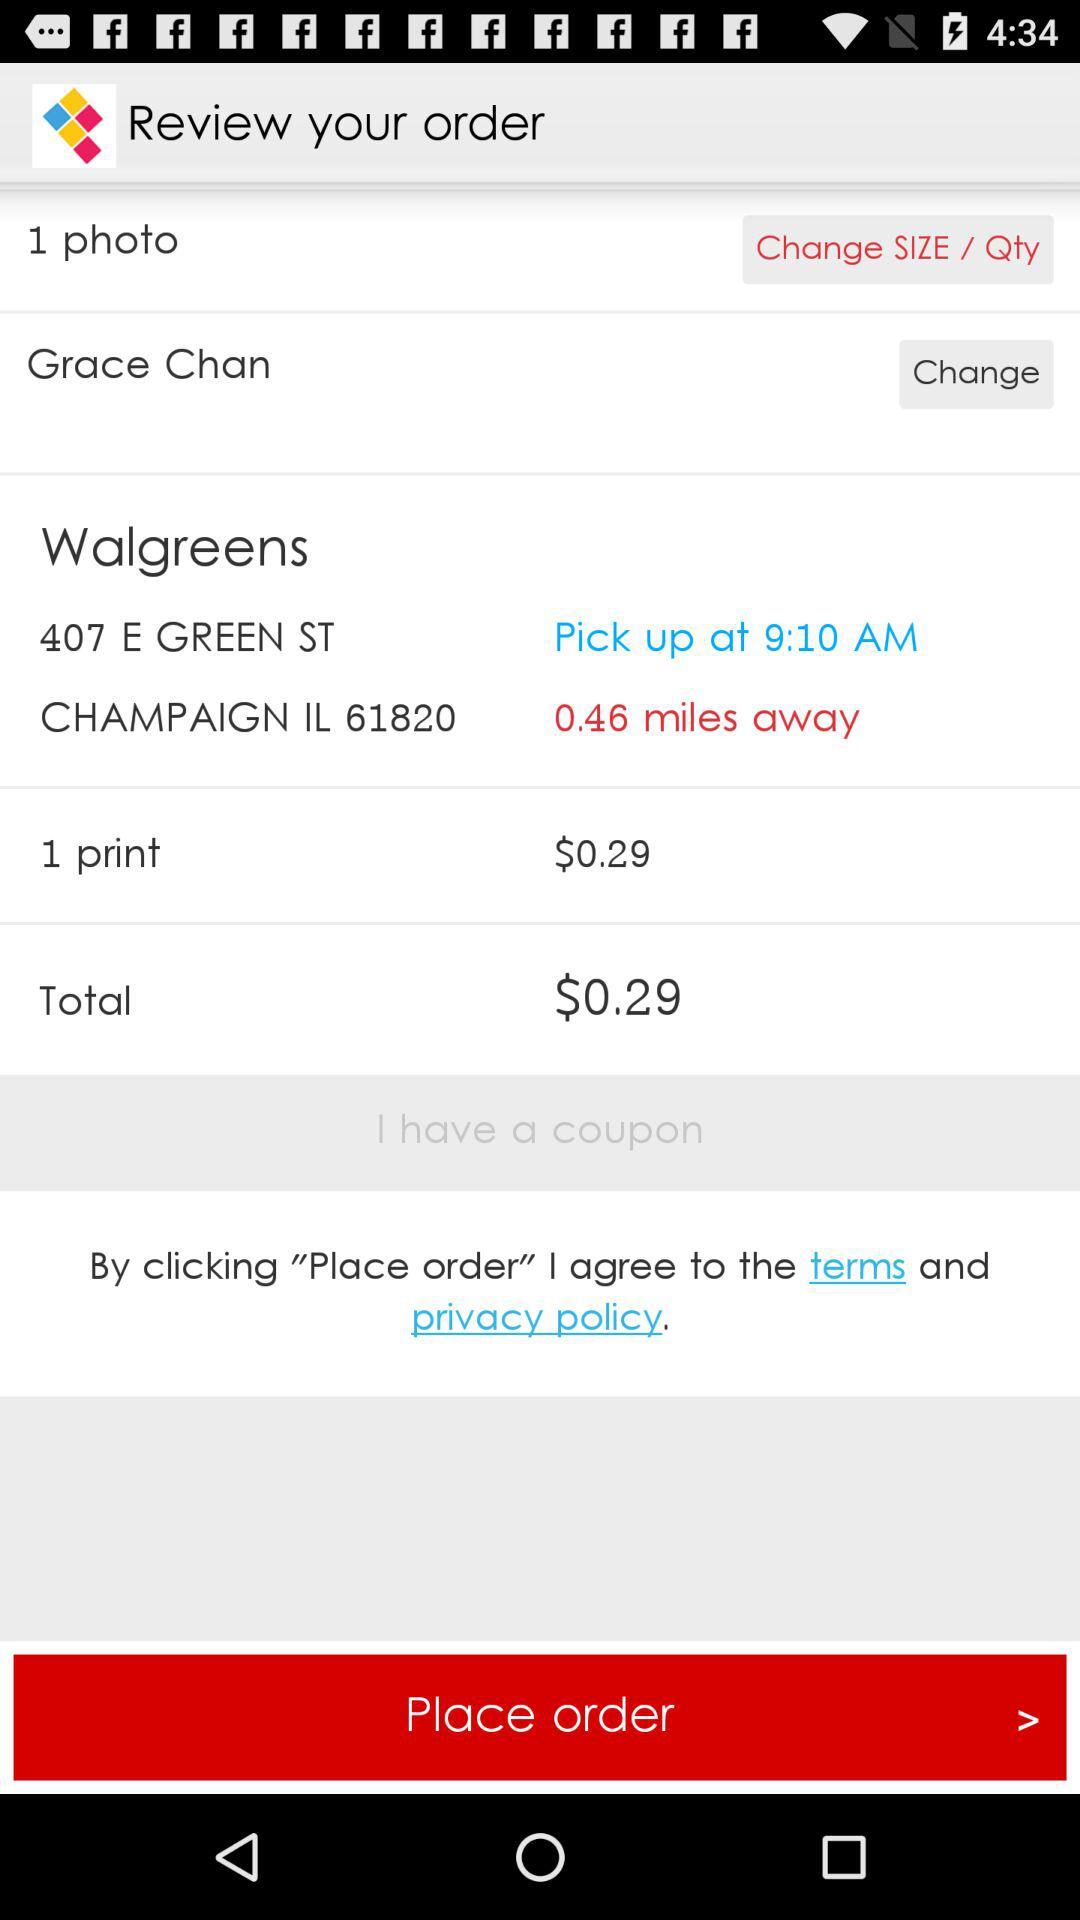How many photos are shown? There is 1 photo shown. 